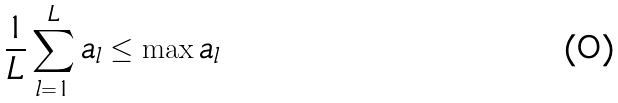<formula> <loc_0><loc_0><loc_500><loc_500>\frac { 1 } { L } \sum _ { l = 1 } ^ { L } a _ { l } \leq \max a _ { l }</formula> 